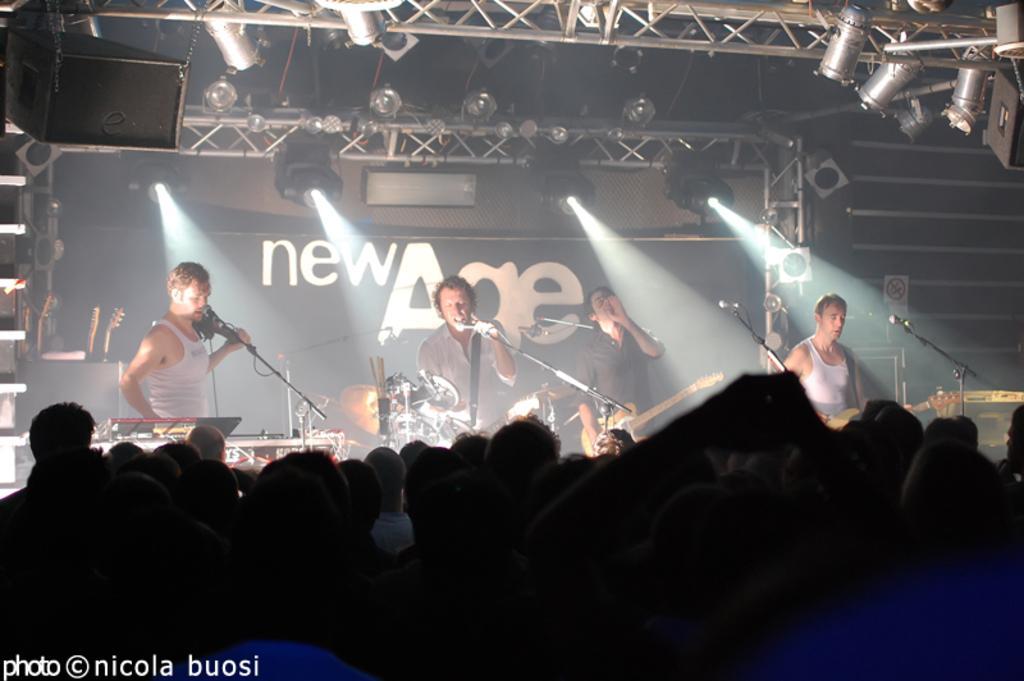Could you give a brief overview of what you see in this image? 4 people are standing on the stage and performing. on the front people are standing and watching them. 2 people at the right of the stage are playing guitar. the person at the center is holding a microphone and singing. the person at the left is carrying a microphone. behind them there is a black background on which new age is written. on the top there are lights. 